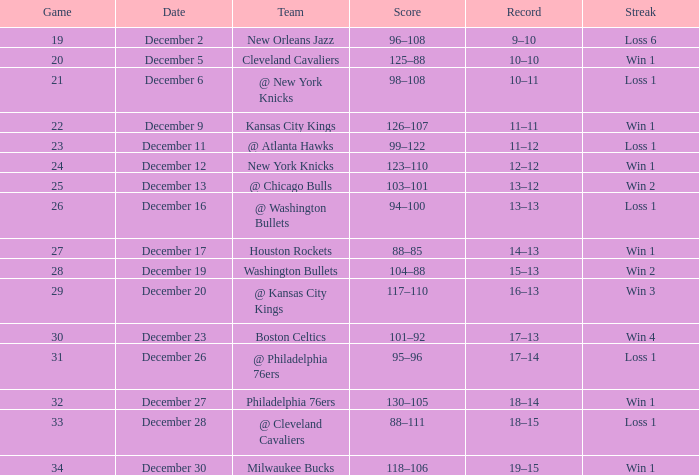What Game had a Score of 101–92? 30.0. 